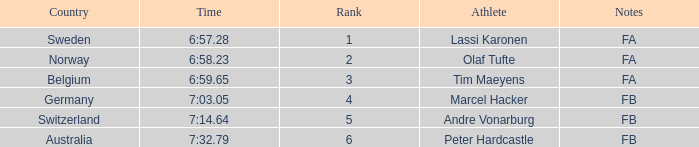What is the lowest rank for Andre Vonarburg, when the notes are FB? 5.0. 